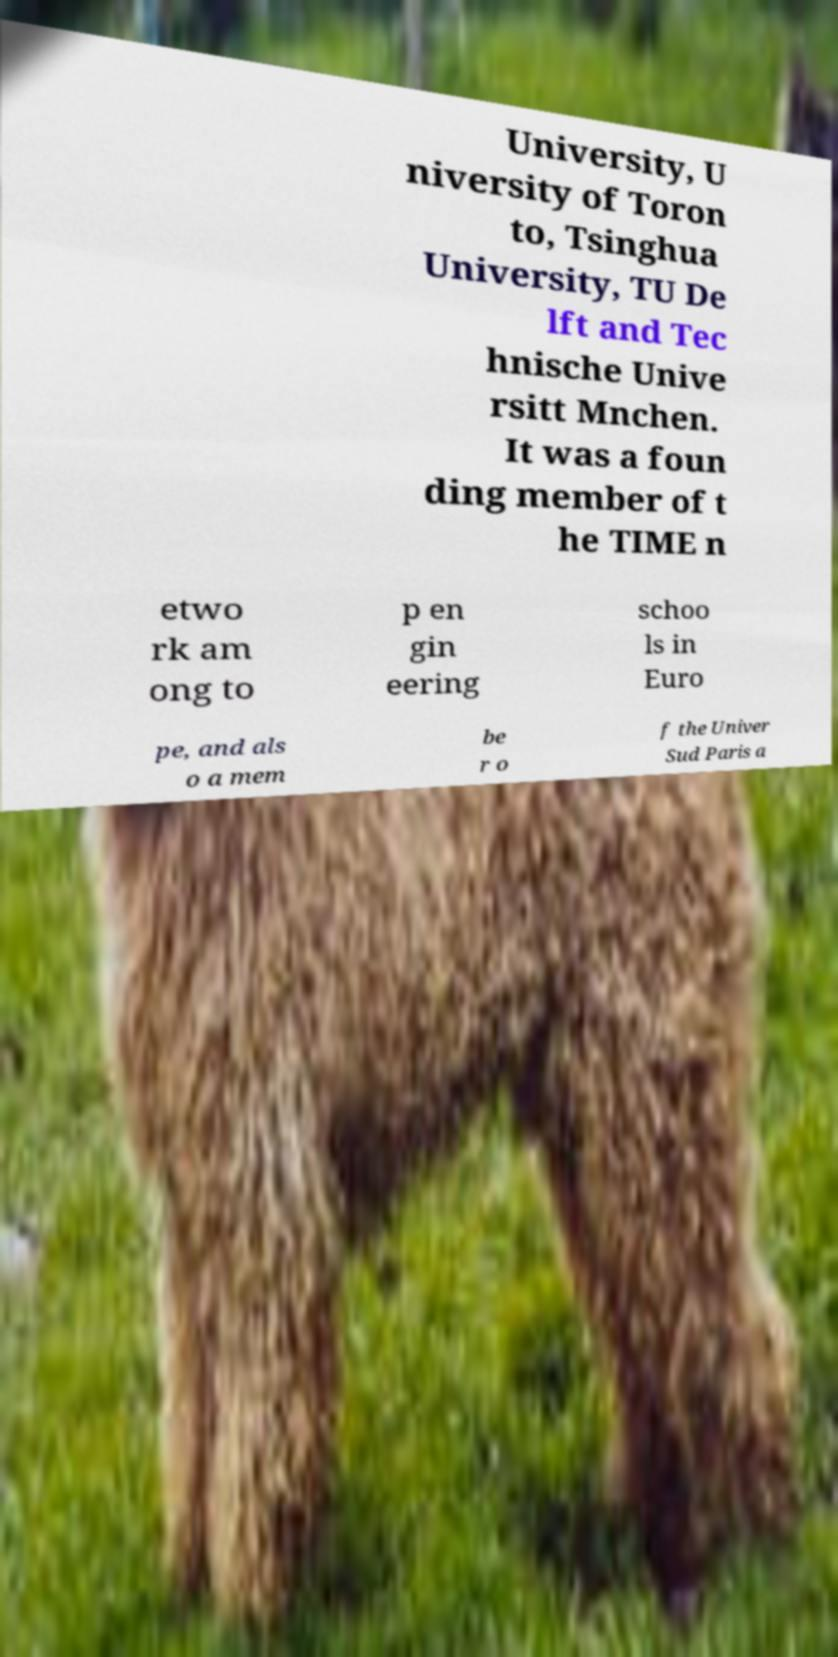For documentation purposes, I need the text within this image transcribed. Could you provide that? University, U niversity of Toron to, Tsinghua University, TU De lft and Tec hnische Unive rsitt Mnchen. It was a foun ding member of t he TIME n etwo rk am ong to p en gin eering schoo ls in Euro pe, and als o a mem be r o f the Univer Sud Paris a 